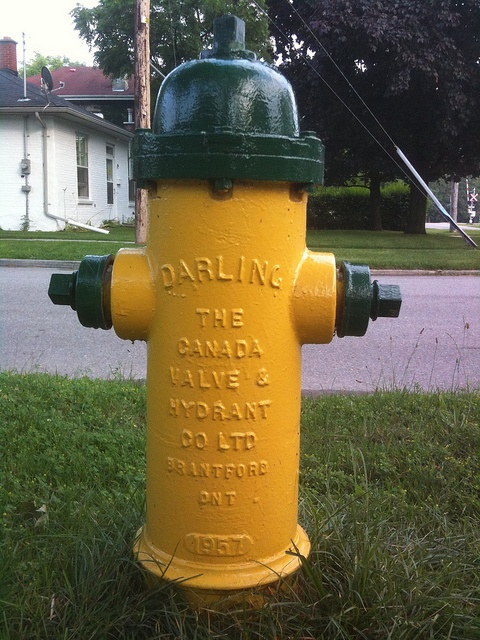Describe the objects in this image and their specific colors. I can see a fire hydrant in ivory, orange, olive, and black tones in this image. 